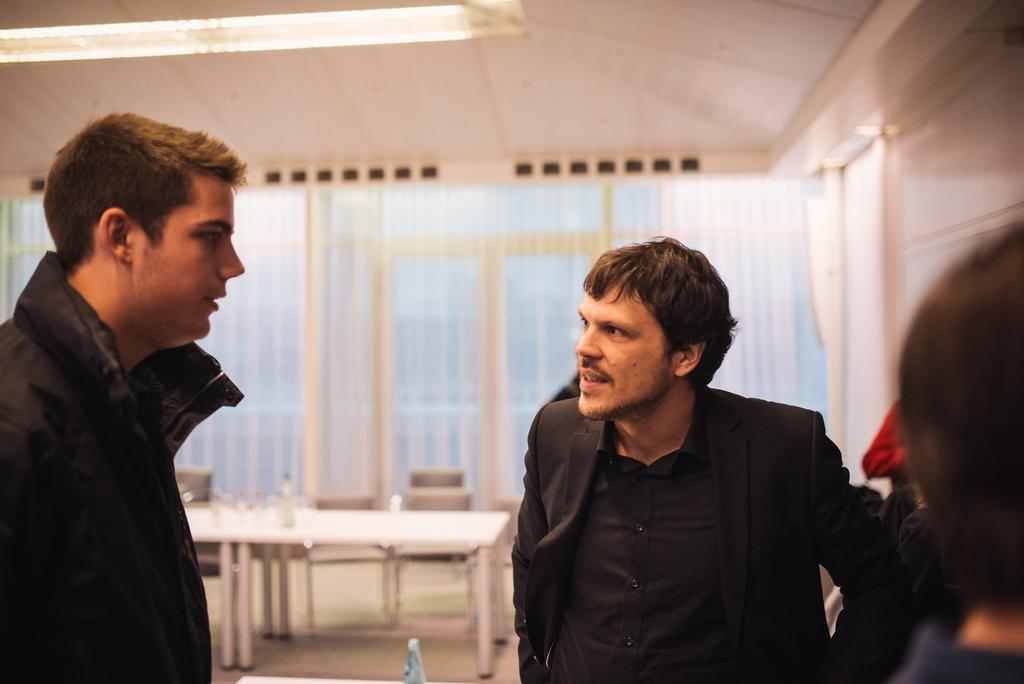How many men are in the picture? There are two men in the picture. What are the men wearing? The men are wearing black jackets. What is located behind the men? There is a table behind the men. What can be seen in the background of the picture? There is a window and a curtain in the background. What is the source of light visible at the top of the image? The light visible at the top of the image could be from a lamp or ceiling light. How deep is the river flowing through the room in the image? There is no river present in the image; it features two men in black jackets, a table, a window, a curtain, and a light source. 